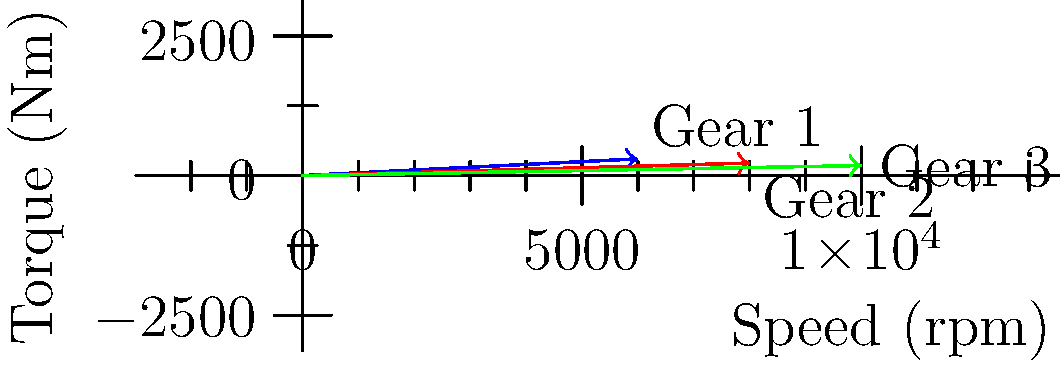In Formula 1, gear ratios play a crucial role in optimizing performance. The graph shows vector representations of torque and speed for three different gear ratios. Which gear ratio provides the highest power output, and how does this relate to the concept of finding the optimal operating point for an F1 engine? To solve this problem, we need to follow these steps:

1) Recall that Power = Torque × Angular Velocity
   In this case, Power = Torque (Nm) × Speed (rpm)

2) For each gear ratio, calculate the power:
   Gear 1: $P_1 = 300 \times 6000 = 1,800,000$
   Gear 2: $P_2 = 225 \times 8000 = 1,800,000$
   Gear 3: $P_3 = 180 \times 10000 = 1,800,000$

3) We can see that all gear ratios produce the same power output. This is because they're all operating points on the engine's power curve.

4) In Formula 1, the optimal operating point is about finding the best balance between torque and speed. Lower gears provide more torque but less speed, while higher gears provide more speed but less torque.

5) The choice of gear depends on the specific requirements of each track section:
   - Gear 1 might be best for low-speed corners where high torque is needed.
   - Gear 3 might be preferable for high-speed straights.
   - Gear 2 offers a balance and might be ideal for medium-speed corners.

6) F1 engineers aim to keep the engine operating near its peak power output across a wide range of speeds, which is why multiple gears with different ratios are crucial.

7) The vectors in the graph visually represent this trade-off: as we move from Gear 1 to Gear 3, we see a decrease in torque but an increase in speed, while maintaining the same power output.
Answer: All gear ratios provide equal power; choice depends on track conditions. 